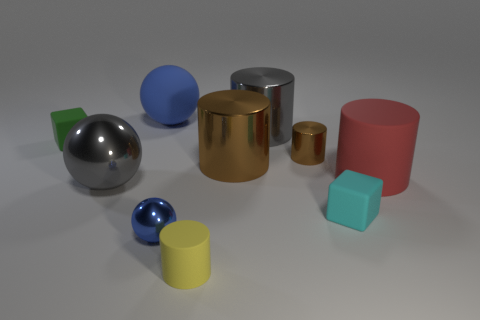Which objects in the image are reflective? The objects with reflective surfaces are the chrome steel sphere, the golden cylinder, and the smaller silver sphere. 